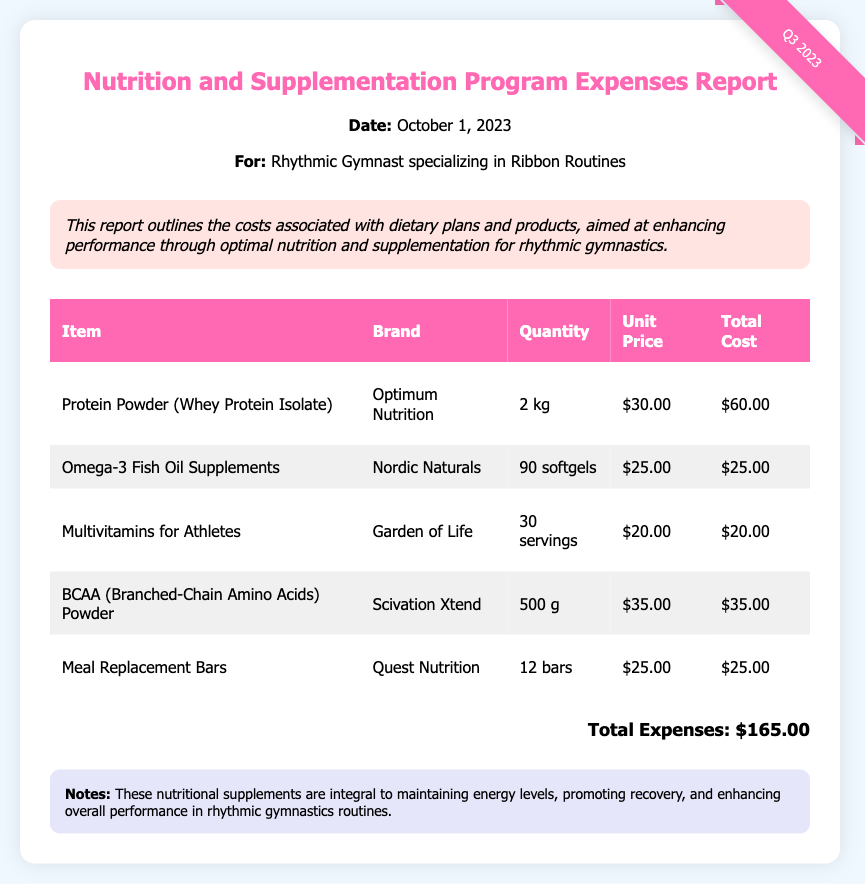What is the total cost of Protein Powder? The total cost of Protein Powder is $60.00 as shown in the table.
Answer: $60.00 How many softgels are in the Omega-3 Fish Oil Supplements? The Omega-3 Fish Oil Supplements contain 90 softgels.
Answer: 90 softgels Who is the brand of the Multivitamins for Athletes? The brand of the Multivitamins for Athletes is Garden of Life, as listed in the document.
Answer: Garden of Life What is the total expense for the Nutrition and Supplementation Program? The total expense is the sum of all individual item costs, which totals $165.00.
Answer: $165.00 How many servings are included in the Multivitamins for Athletes? The Multivitamins for Athletes offer 30 servings as noted in the report.
Answer: 30 servings Which item has a unit price of $25.00? The Omega-3 Fish Oil Supplements have a unit price of $25.00 as listed in the table.
Answer: Omega-3 Fish Oil Supplements What is the date of this report? The report date is October 1, 2023, mentioned in the document.
Answer: October 1, 2023 What type of product is listed as BCAA? BCAA is specified as Branched-Chain Amino Acids Powder in the report.
Answer: Branched-Chain Amino Acids Powder What is the purpose of the notes section? The notes section emphasizes the importance of the supplements for performance in rhythmic gymnastics.
Answer: Importance of supplements for performance 